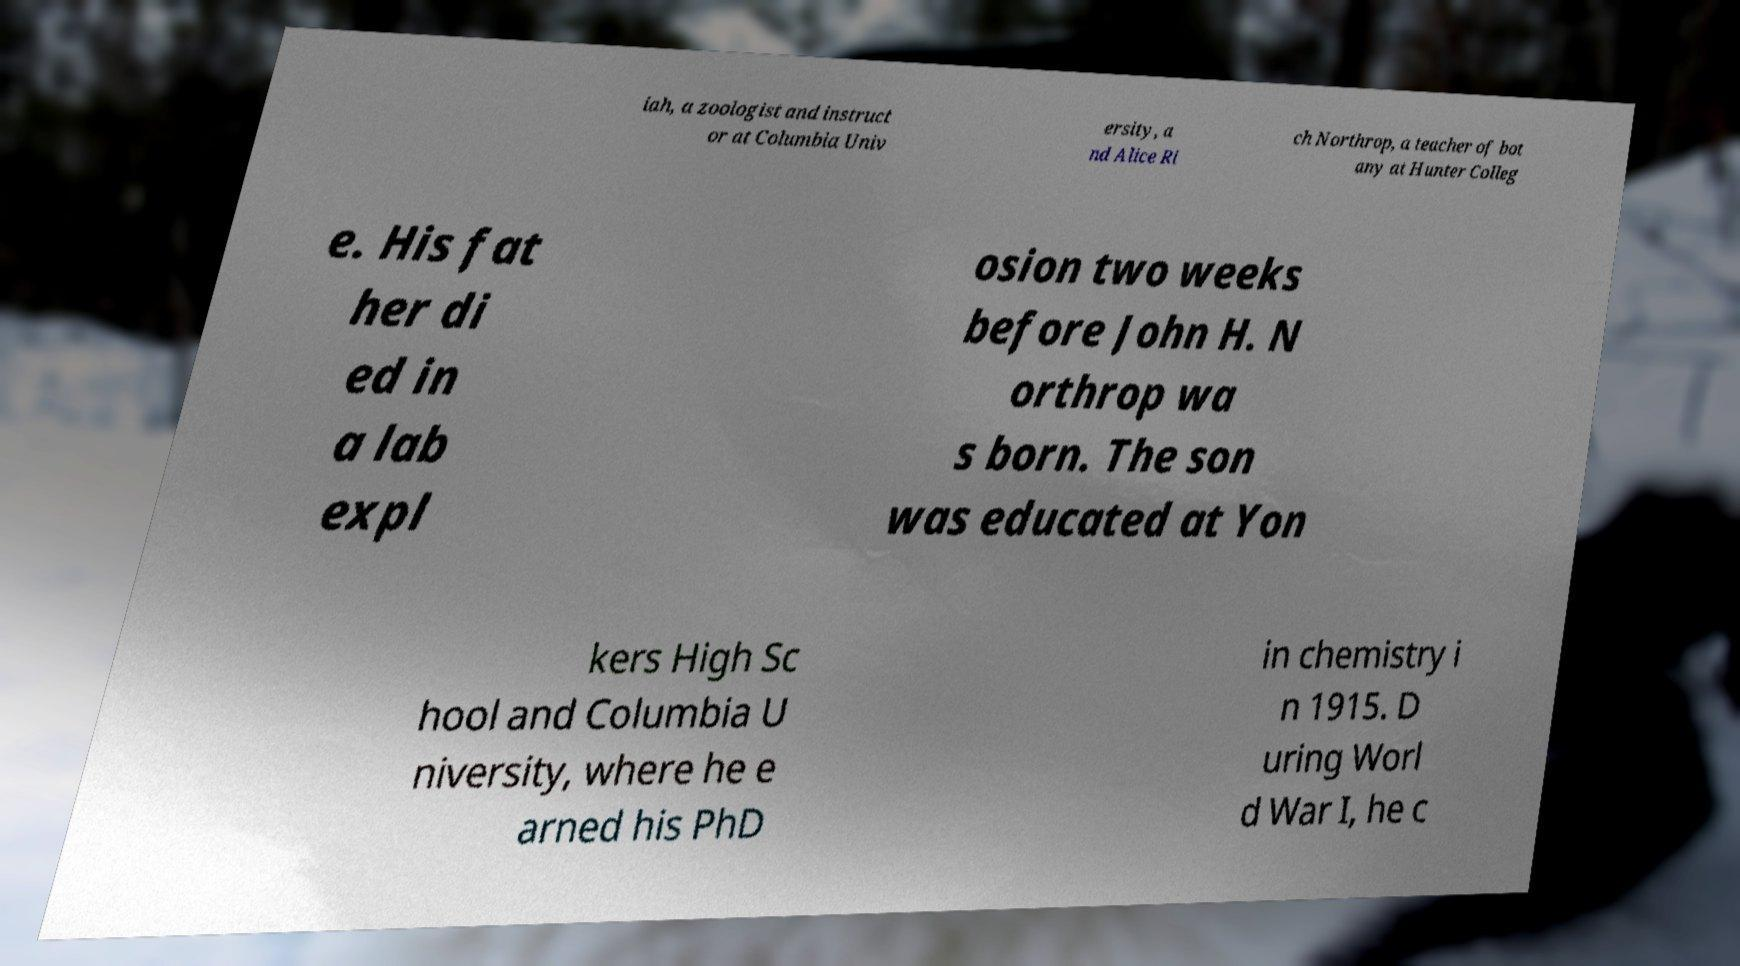Can you read and provide the text displayed in the image?This photo seems to have some interesting text. Can you extract and type it out for me? iah, a zoologist and instruct or at Columbia Univ ersity, a nd Alice Ri ch Northrop, a teacher of bot any at Hunter Colleg e. His fat her di ed in a lab expl osion two weeks before John H. N orthrop wa s born. The son was educated at Yon kers High Sc hool and Columbia U niversity, where he e arned his PhD in chemistry i n 1915. D uring Worl d War I, he c 